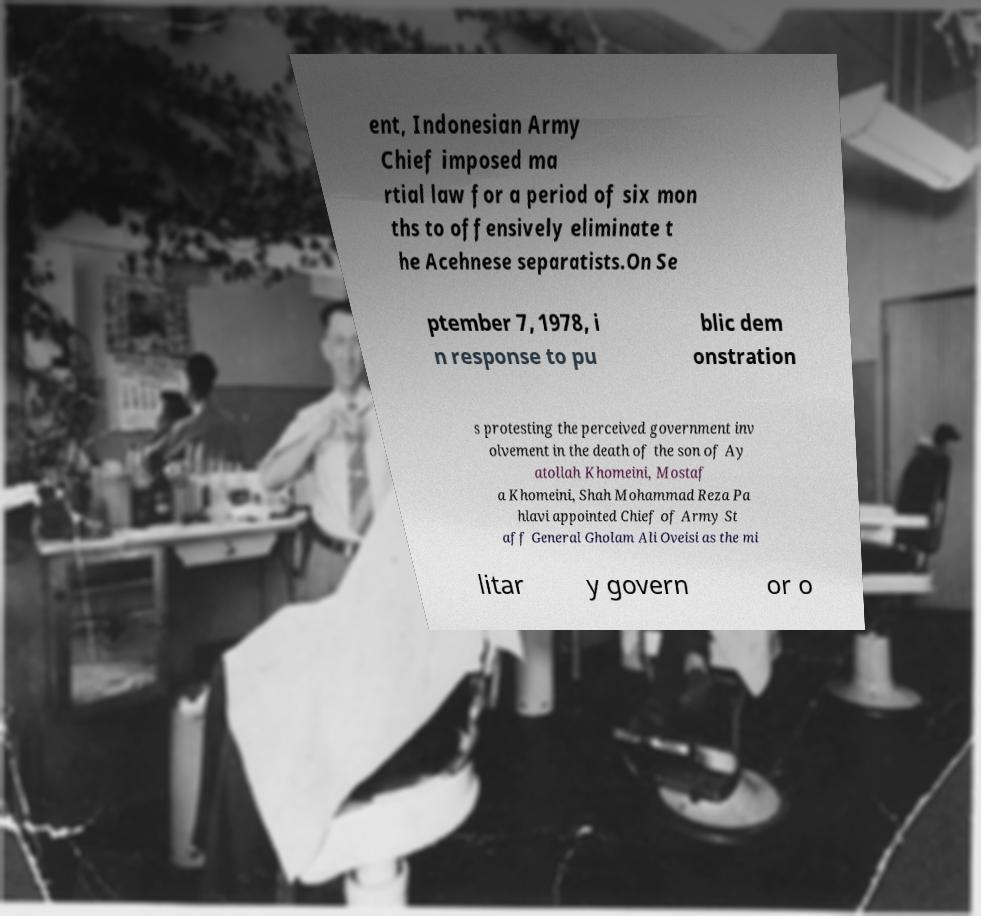Could you extract and type out the text from this image? ent, Indonesian Army Chief imposed ma rtial law for a period of six mon ths to offensively eliminate t he Acehnese separatists.On Se ptember 7, 1978, i n response to pu blic dem onstration s protesting the perceived government inv olvement in the death of the son of Ay atollah Khomeini, Mostaf a Khomeini, Shah Mohammad Reza Pa hlavi appointed Chief of Army St aff General Gholam Ali Oveisi as the mi litar y govern or o 